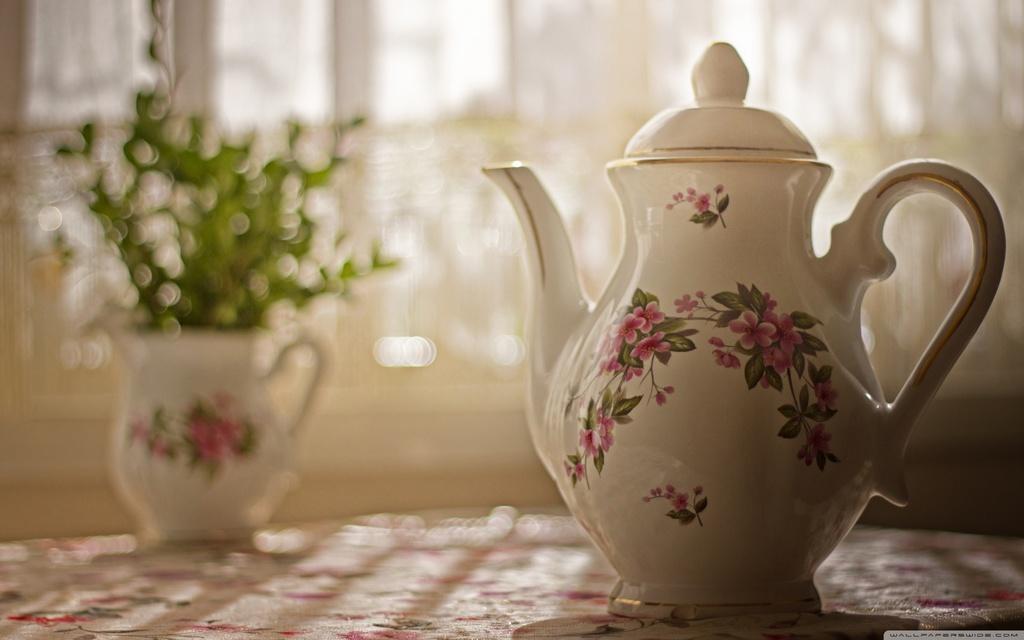Can you describe this image briefly? In this picture we can see a house plant and a kettle. Background is blurry. 